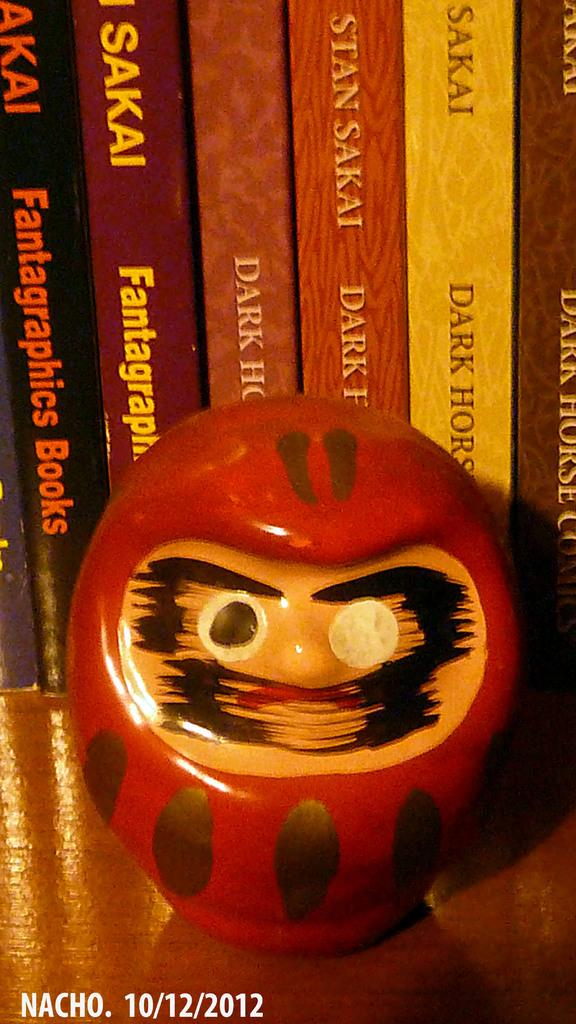<image>
Create a compact narrative representing the image presented. A SMALL RED SCULPTURE WITH A MISSING PUPIL IN FRONT OF BOOKS BY SAKAI. DATE 10/12/2012 